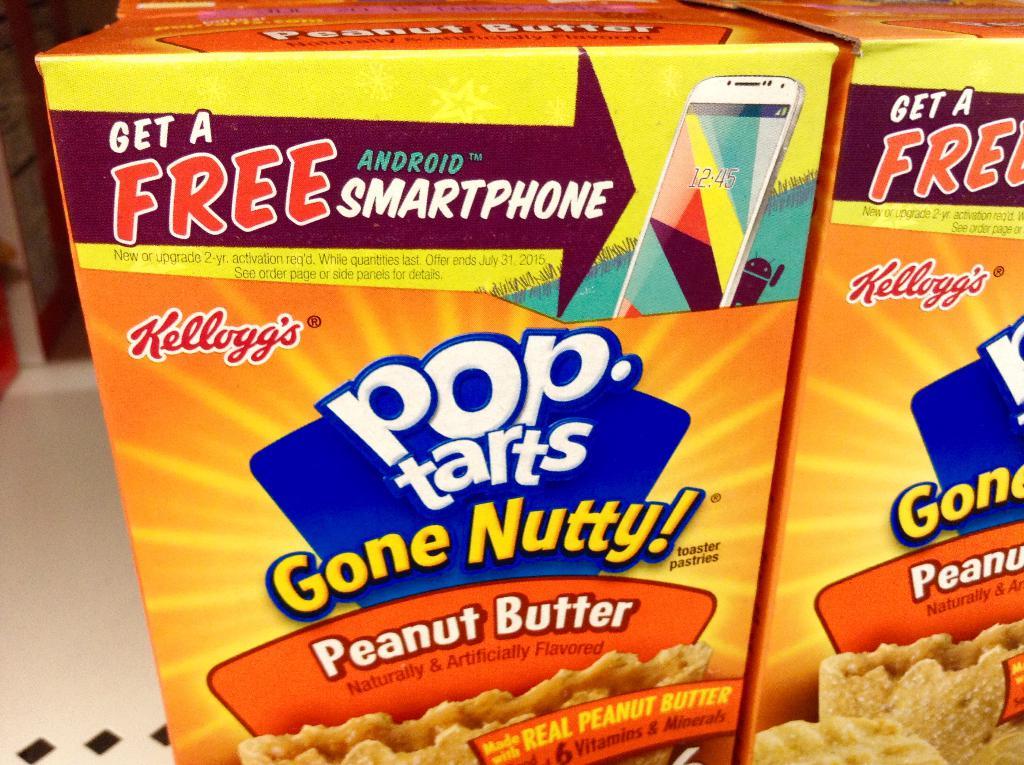What type of pop tart is this?
Offer a terse response. Peanut butter. What can you get for free?
Your answer should be very brief. Android smartphone. 